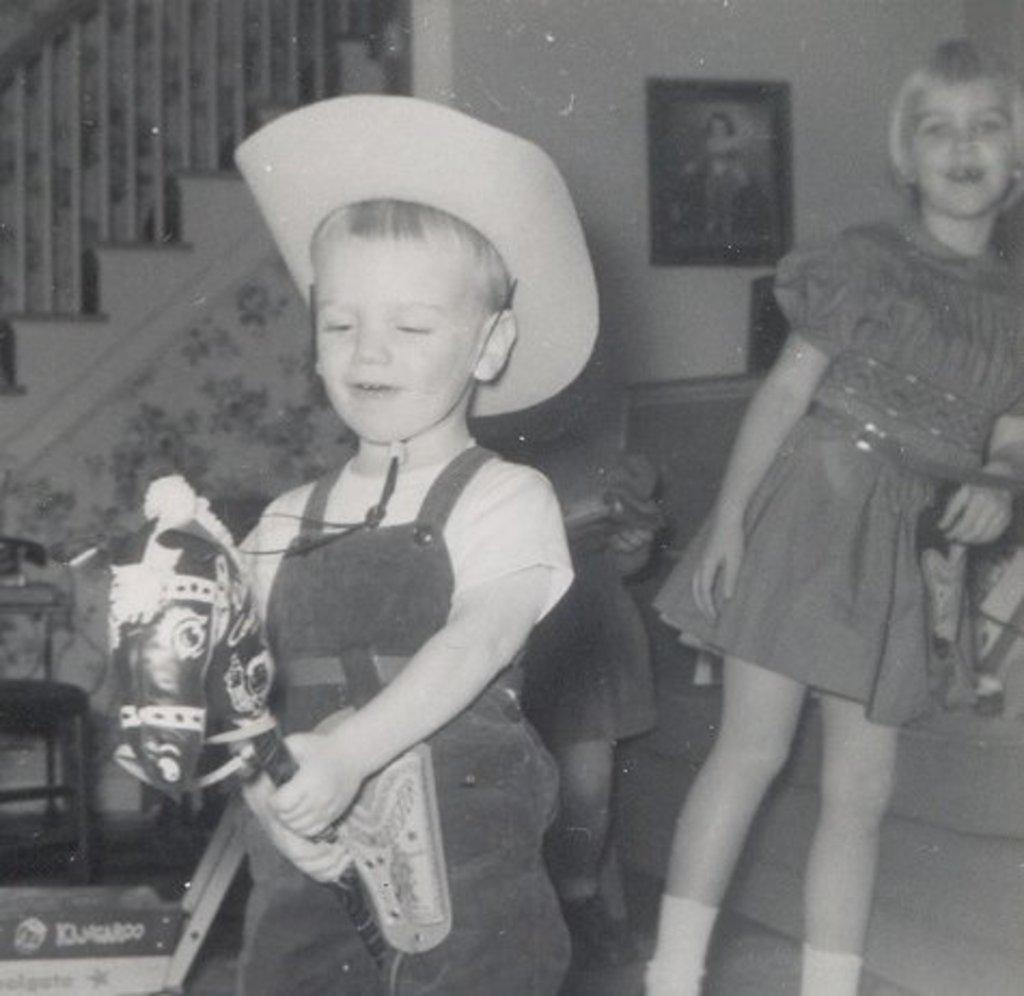What is the color scheme of the image? The image is black and white. How many children are present in the image? There are 2 children in the image. Can you describe the clothing of one of the children? One child is wearing a hat. What is the child wearing a hat holding? The child wearing a hat is holding a horse toy. What architectural feature can be seen in the image? There are stairs in the image. What safety feature is present in the image? There is a railing in the image. What object might be used for displaying a photograph? There is a photo frame in the image. What year is depicted in the image? The image does not depict a specific year; it is a black and white photograph of two children, one of whom is wearing a hat and holding a horse toy. What type of mine is visible in the image? There is no mine present in the image; it features two children, stairs, a railing, and a photo frame. 